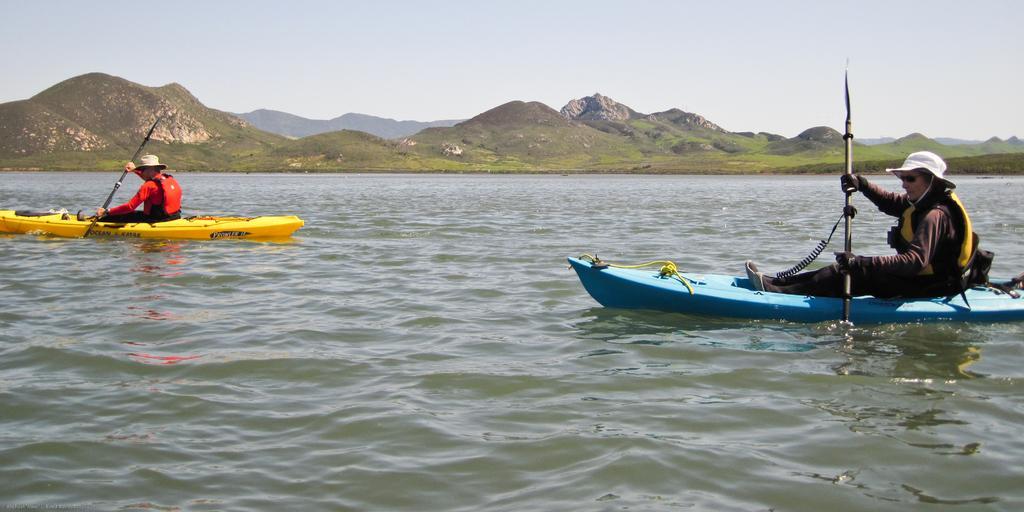Can you describe this image briefly? There are two people kayaking on the water both the sides of the image and there are mountains and sky in the background area. 